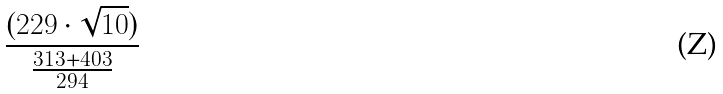<formula> <loc_0><loc_0><loc_500><loc_500>\frac { ( 2 2 9 \cdot \sqrt { 1 0 } ) } { \frac { 3 1 3 + 4 0 3 } { 2 9 4 } }</formula> 